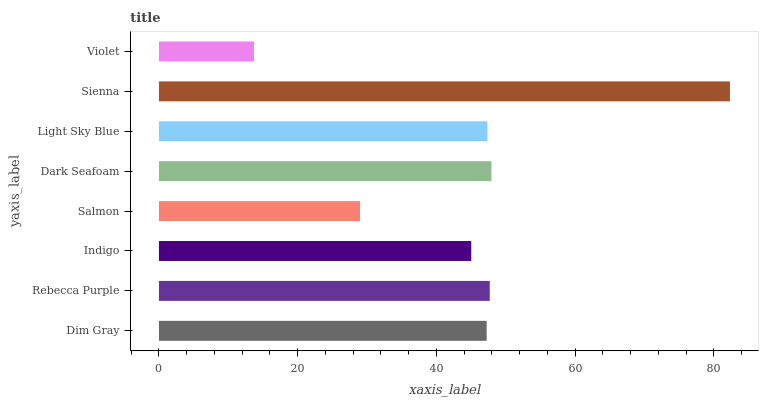Is Violet the minimum?
Answer yes or no. Yes. Is Sienna the maximum?
Answer yes or no. Yes. Is Rebecca Purple the minimum?
Answer yes or no. No. Is Rebecca Purple the maximum?
Answer yes or no. No. Is Rebecca Purple greater than Dim Gray?
Answer yes or no. Yes. Is Dim Gray less than Rebecca Purple?
Answer yes or no. Yes. Is Dim Gray greater than Rebecca Purple?
Answer yes or no. No. Is Rebecca Purple less than Dim Gray?
Answer yes or no. No. Is Light Sky Blue the high median?
Answer yes or no. Yes. Is Dim Gray the low median?
Answer yes or no. Yes. Is Indigo the high median?
Answer yes or no. No. Is Violet the low median?
Answer yes or no. No. 